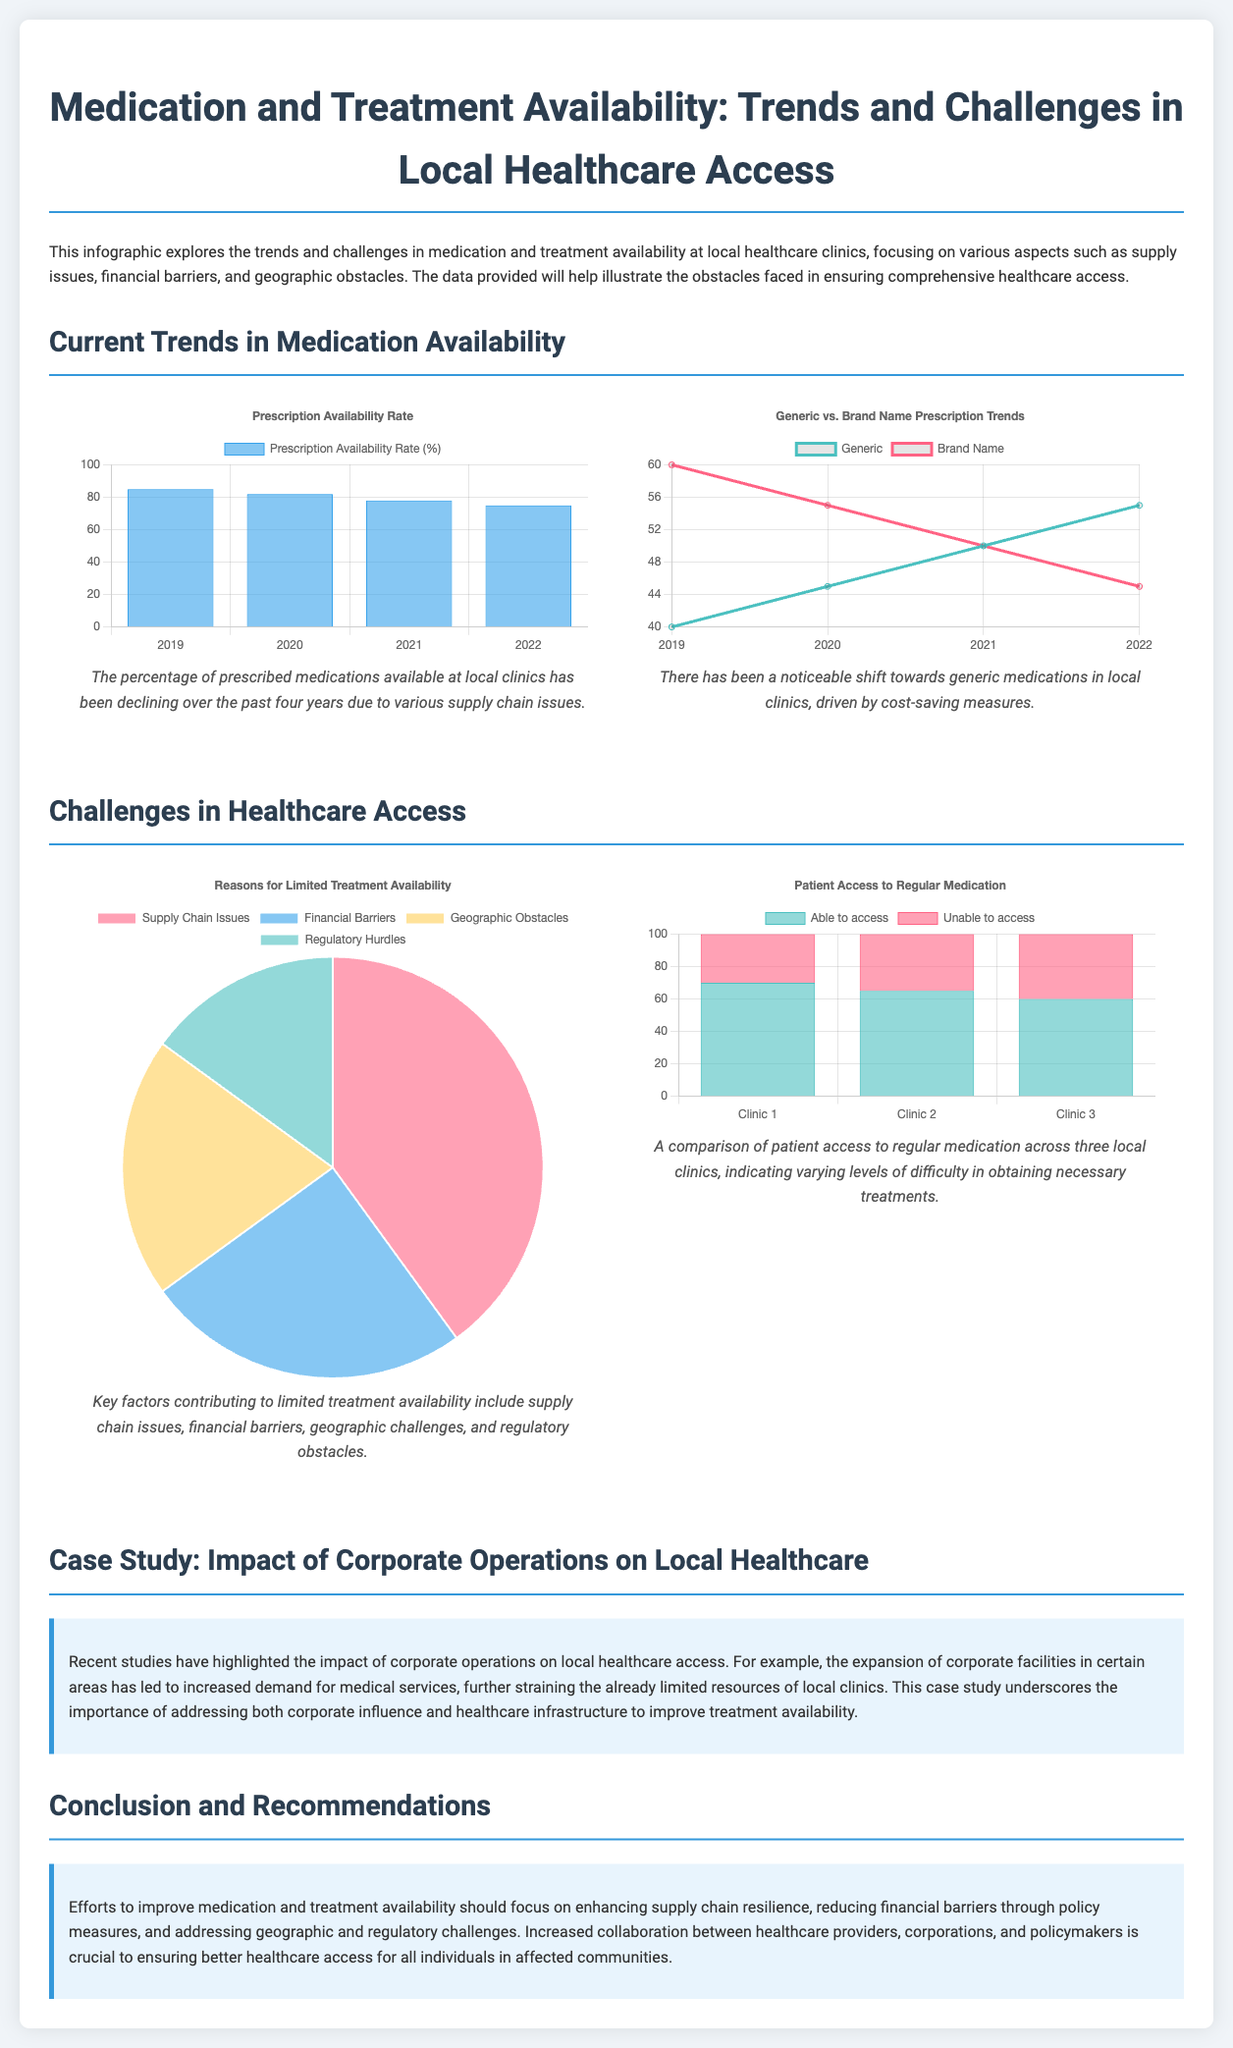What was the prescription availability rate in 2022? The prescription availability rate for 2022 is indicated in the chart showing the rate over four years.
Answer: 75% What is the trend observed in the use of generic medications from 2019 to 2022? The chart shows a consistent increase in the percentage of generic medications prescribed over those years.
Answer: Increasing What are the four key reasons for limited treatment availability? The pie chart provides insights into the primary reasons contributing to limited treatment availability.
Answer: Supply Chain Issues, Financial Barriers, Geographic Obstacles, Regulatory Hurdles Which clinic showed the highest percentage of patients able to access medication? The bar chart comparing patient access shows which clinic performed best in terms of access to medication.
Answer: Clinic 1 What percentage of patients were unable to access medication at Clinic 3? The chart displays the percentage of patients unable to access medication at three different clinics.
Answer: 40% What observation can be made about the availability of brand name medications from 2019 to 2022? The line chart depicts a decline in the percentage of brand name medications prescribed over these years.
Answer: Declining What conclusion is suggested about corporate operations' impact on local healthcare? The case study section discusses the effects that corporate facilities have on healthcare access in local communities.
Answer: Increased demand How should efforts to improve medication availability be focused, according to the document? The conclusion section outlines recommendations for enhancing medication and treatment availability.
Answer: Enhancing supply chain resilience, reducing financial barriers, addressing geographic obstacles 